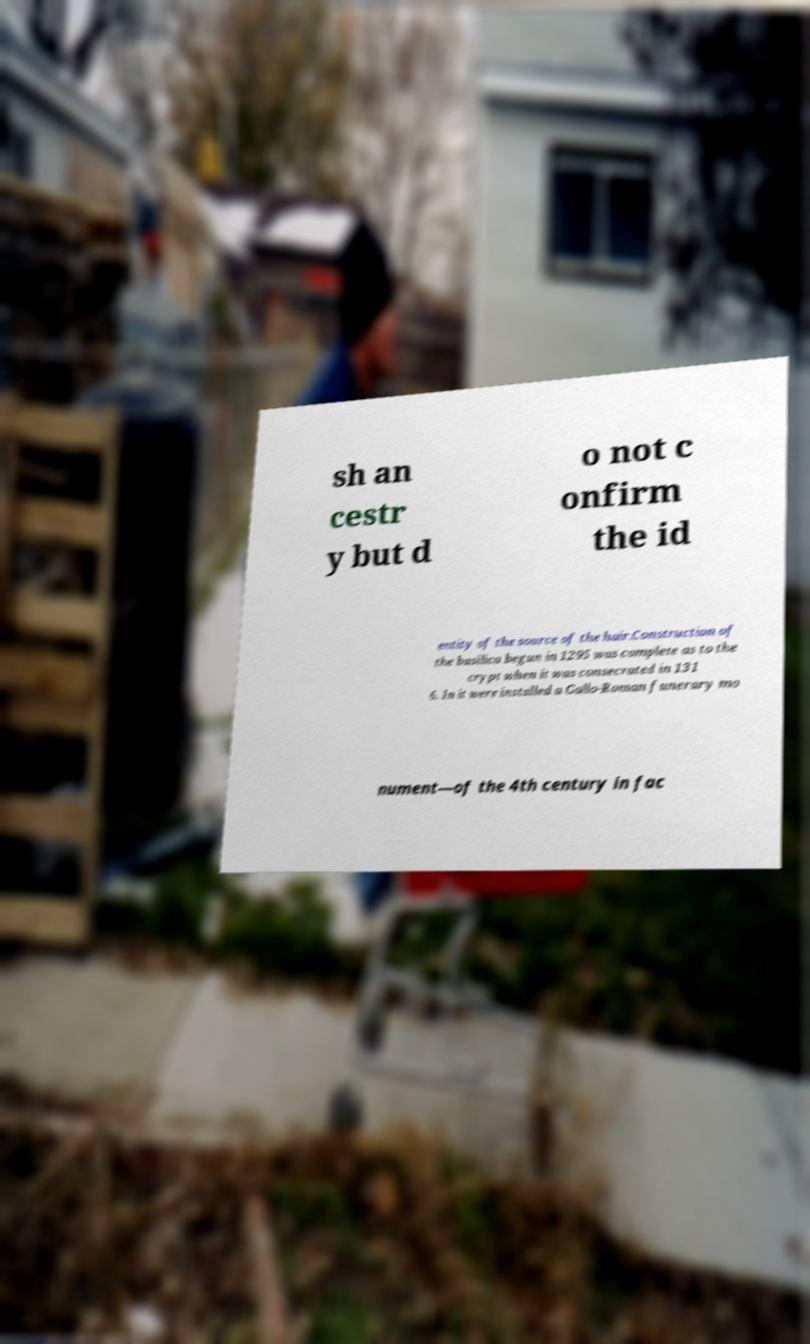For documentation purposes, I need the text within this image transcribed. Could you provide that? sh an cestr y but d o not c onfirm the id entity of the source of the hair.Construction of the basilica begun in 1295 was complete as to the crypt when it was consecrated in 131 6. In it were installed a Gallo-Roman funerary mo nument—of the 4th century in fac 